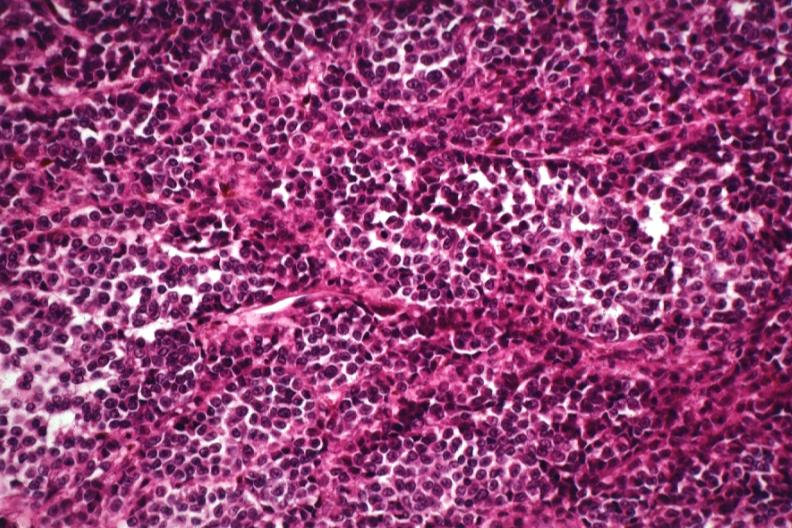s normal ovary present?
Answer the question using a single word or phrase. No 